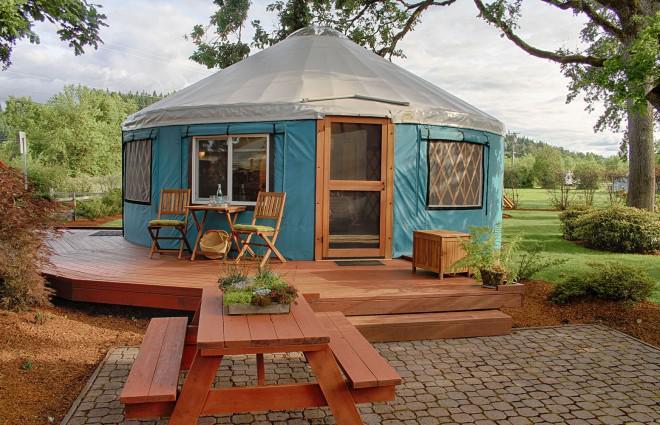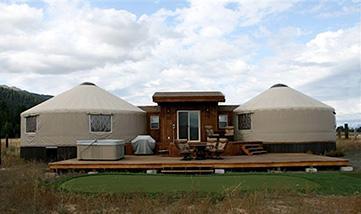The first image is the image on the left, the second image is the image on the right. Examine the images to the left and right. Is the description "There are two white huts near each other in the image on the right." accurate? Answer yes or no. Yes. The first image is the image on the left, the second image is the image on the right. For the images shown, is this caption "One image contains two round structures wrapped in greenish-blue material and situated among trees." true? Answer yes or no. No. 